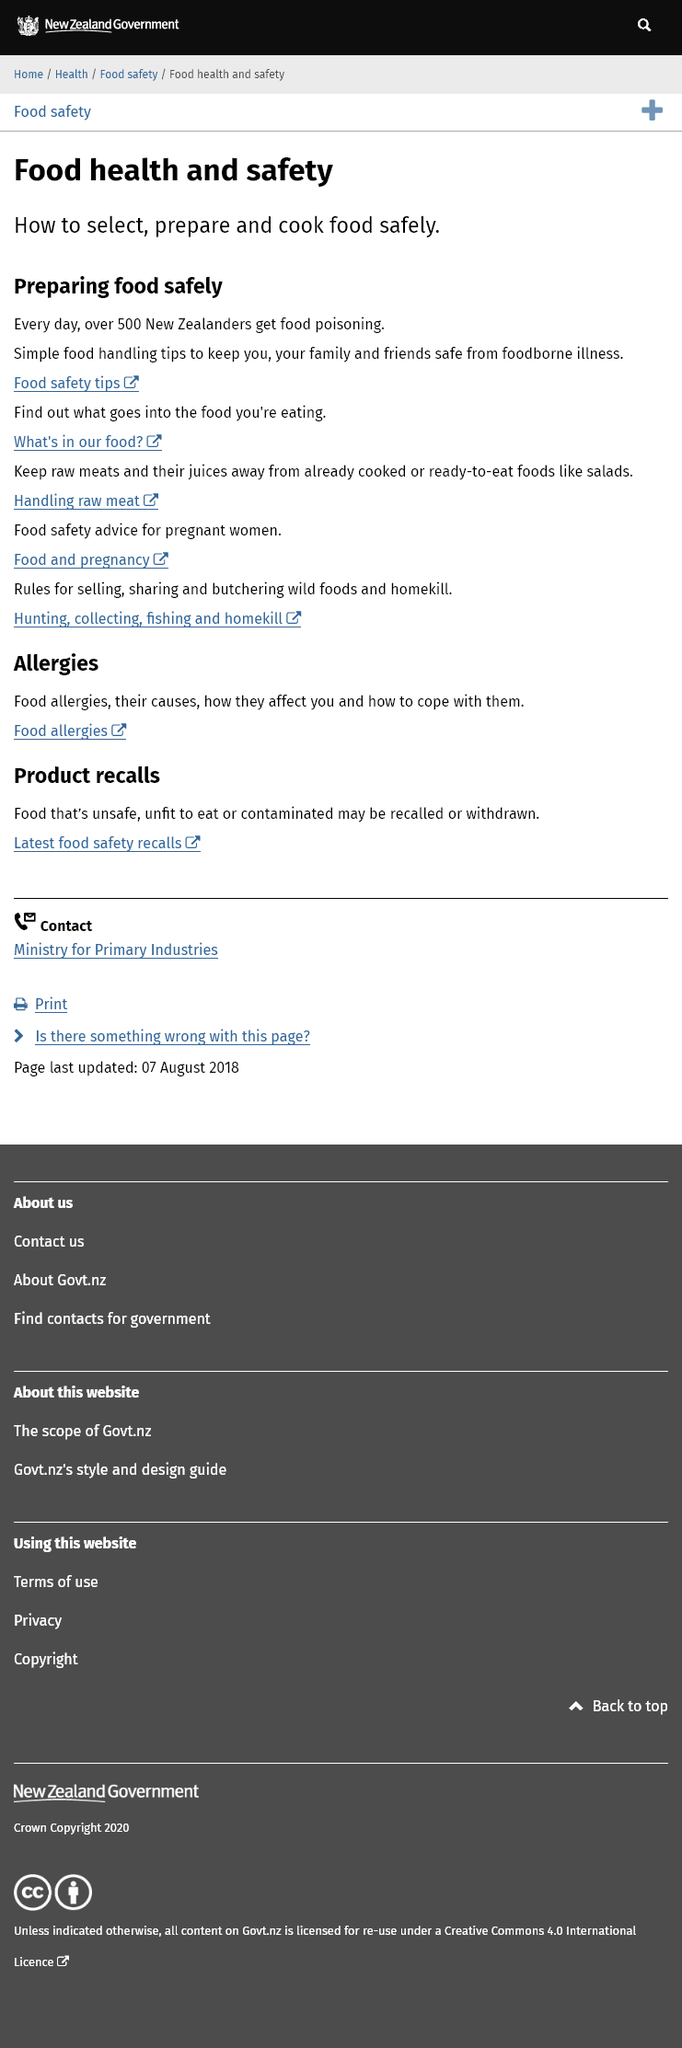Indicate a few pertinent items in this graphic. It is estimated that on a daily basis, approximately 500 New Zealanders contract food poisoning. Yes, there is further information available via links regarding food safety tips and handling raw meat. Yes, it is advisable to keep raw meats and their juices away from already cooked foods to avoid contamination. 